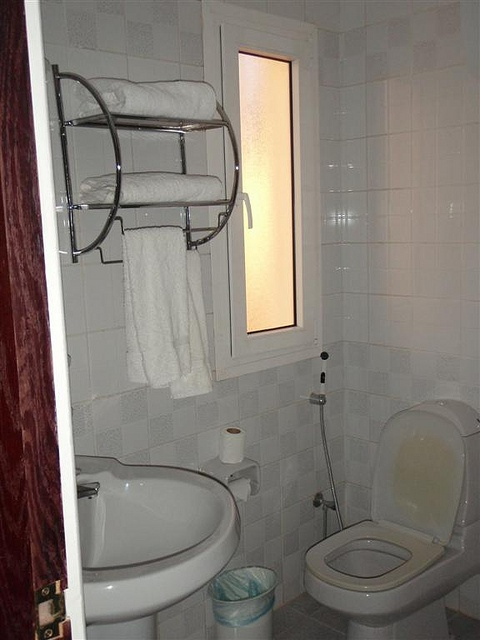Describe the objects in this image and their specific colors. I can see toilet in black and gray tones and sink in black, darkgray, and gray tones in this image. 